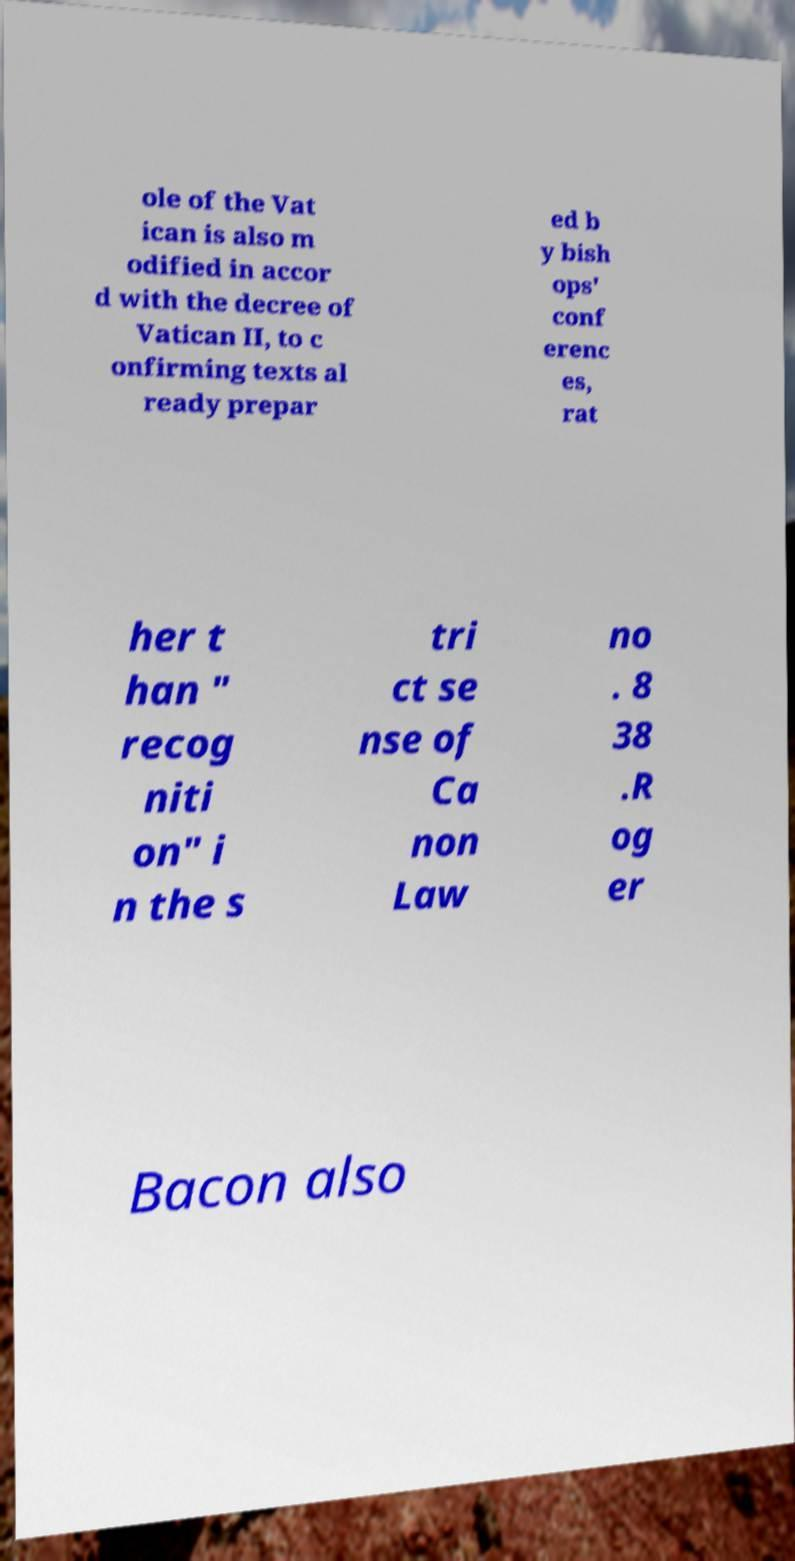Please identify and transcribe the text found in this image. ole of the Vat ican is also m odified in accor d with the decree of Vatican II, to c onfirming texts al ready prepar ed b y bish ops' conf erenc es, rat her t han " recog niti on" i n the s tri ct se nse of Ca non Law no . 8 38 .R og er Bacon also 